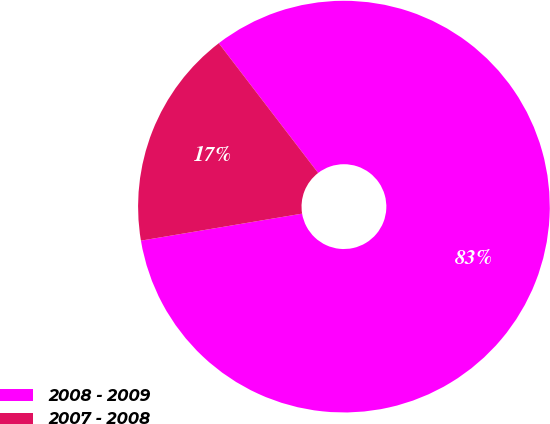Convert chart. <chart><loc_0><loc_0><loc_500><loc_500><pie_chart><fcel>2008 - 2009<fcel>2007 - 2008<nl><fcel>82.76%<fcel>17.24%<nl></chart> 